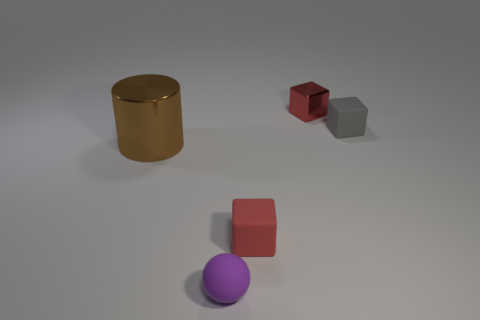Is the number of small rubber cubes that are in front of the metal cylinder the same as the number of purple matte spheres left of the ball?
Offer a very short reply. No. There is a block that is made of the same material as the brown object; what color is it?
Provide a succinct answer. Red. There is a sphere; does it have the same color as the small matte block that is behind the big brown metallic cylinder?
Make the answer very short. No. Is there a tiny gray rubber block that is left of the object that is on the right side of the thing behind the tiny gray matte object?
Your answer should be compact. No. What shape is the red thing that is the same material as the purple sphere?
Give a very brief answer. Cube. Is there anything else that has the same shape as the gray object?
Your answer should be compact. Yes. The brown metal object is what shape?
Your response must be concise. Cylinder. There is a tiny red thing that is behind the brown metal cylinder; is it the same shape as the tiny purple object?
Give a very brief answer. No. Is the number of purple rubber things on the left side of the brown metal object greater than the number of purple rubber balls behind the purple ball?
Offer a terse response. No. What number of other things are the same size as the brown shiny thing?
Provide a short and direct response. 0. 